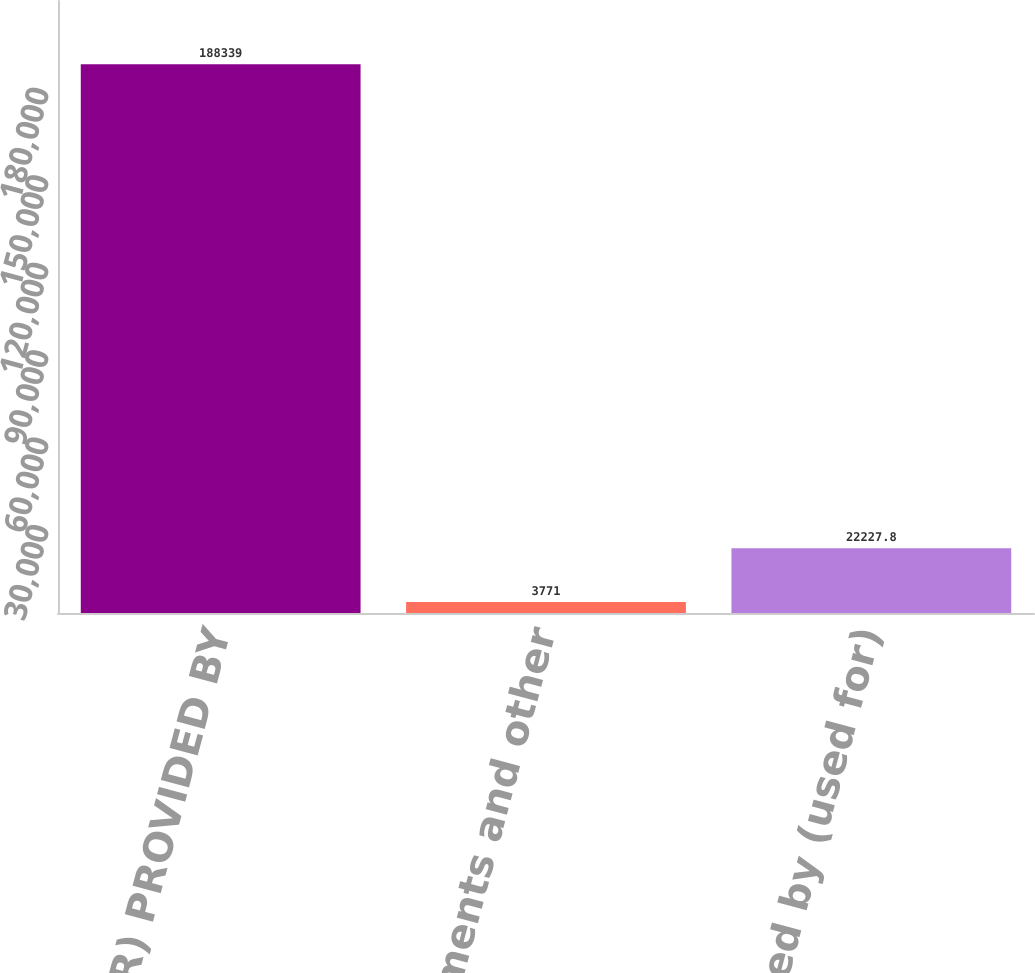<chart> <loc_0><loc_0><loc_500><loc_500><bar_chart><fcel>CASH (USED FOR) PROVIDED BY<fcel>Deposits investments and other<fcel>Cash provided by (used for)<nl><fcel>188339<fcel>3771<fcel>22227.8<nl></chart> 